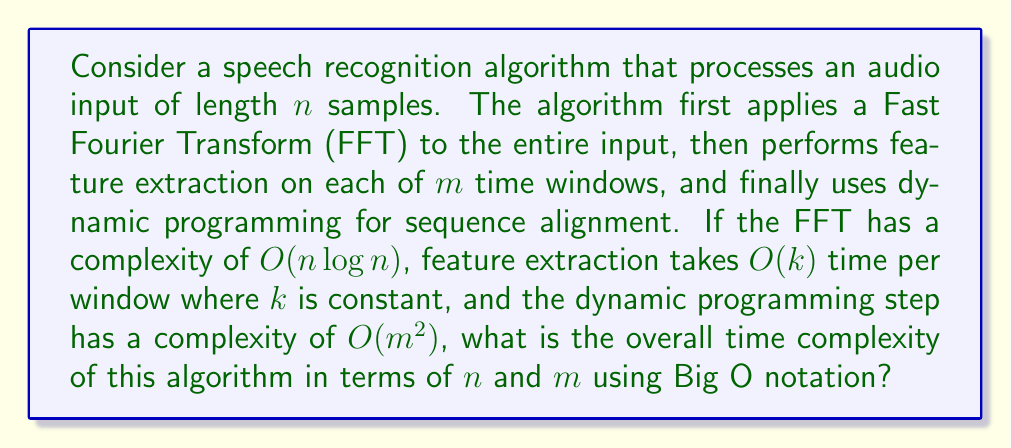Teach me how to tackle this problem. Let's break down the problem step-by-step:

1. Fast Fourier Transform (FFT):
   - Complexity: $O(n \log n)$
   - This is applied to the entire input of length $n$

2. Feature Extraction:
   - Complexity per window: $O(k)$, where $k$ is constant
   - Number of windows: $m$
   - Total complexity for feature extraction: $O(m \cdot k) = O(m)$

3. Dynamic Programming for Sequence Alignment:
   - Complexity: $O(m^2)$

To find the overall complexity, we need to sum these components:

$$O(n \log n) + O(m) + O(m^2)$$

Now, we need to simplify this expression:

1. $O(m)$ is dominated by $O(m^2)$, so we can drop $O(m)$
2. We're left with $O(n \log n) + O(m^2)$

We cannot simplify this further without knowing the relationship between $n$ and $m$. In speech recognition, typically $m < n$, but we don't know the exact relationship. Therefore, we keep both terms.

The final complexity is $O(n \log n + m^2)$.
Answer: $O(n \log n + m^2)$ 